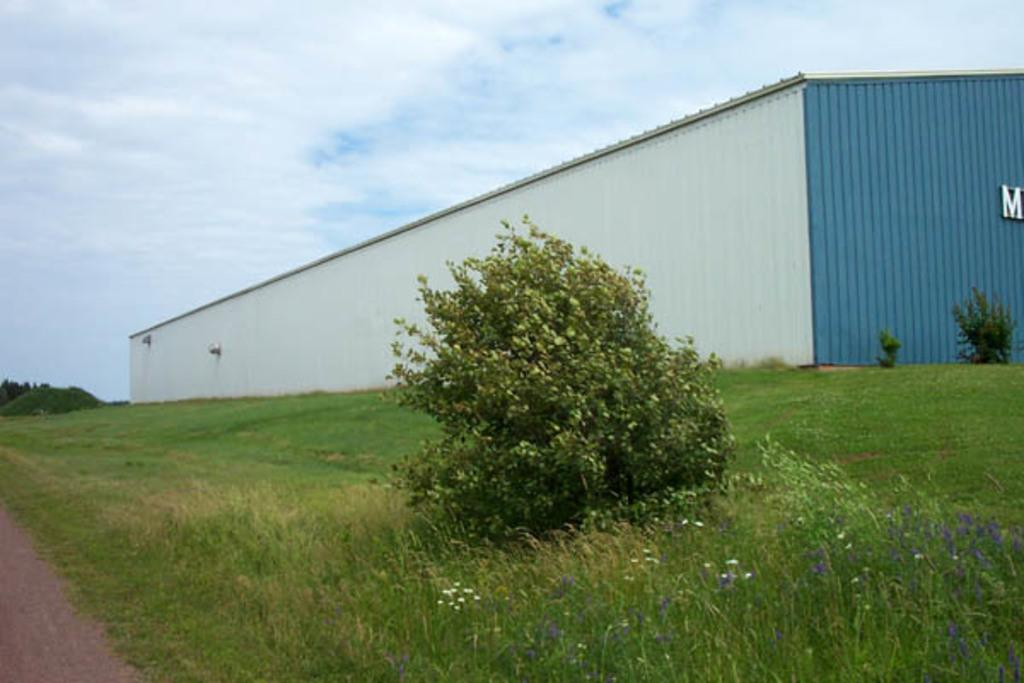What type of structure is visible in the image? There is a building with a roof in the image. What kind of vegetation can be seen in the image? There are plants with flowers and grass present in the image. Can you describe the group of trees in the image? There is a group of trees in the image. What is visible in the sky in the image? The sky is visible in the image and appears cloudy. What language are the pets speaking in the image? There are no pets present in the image, and therefore they cannot be speaking any language. What is your uncle doing in the image? There is no reference to an uncle in the image, so it is not possible to answer that question. 